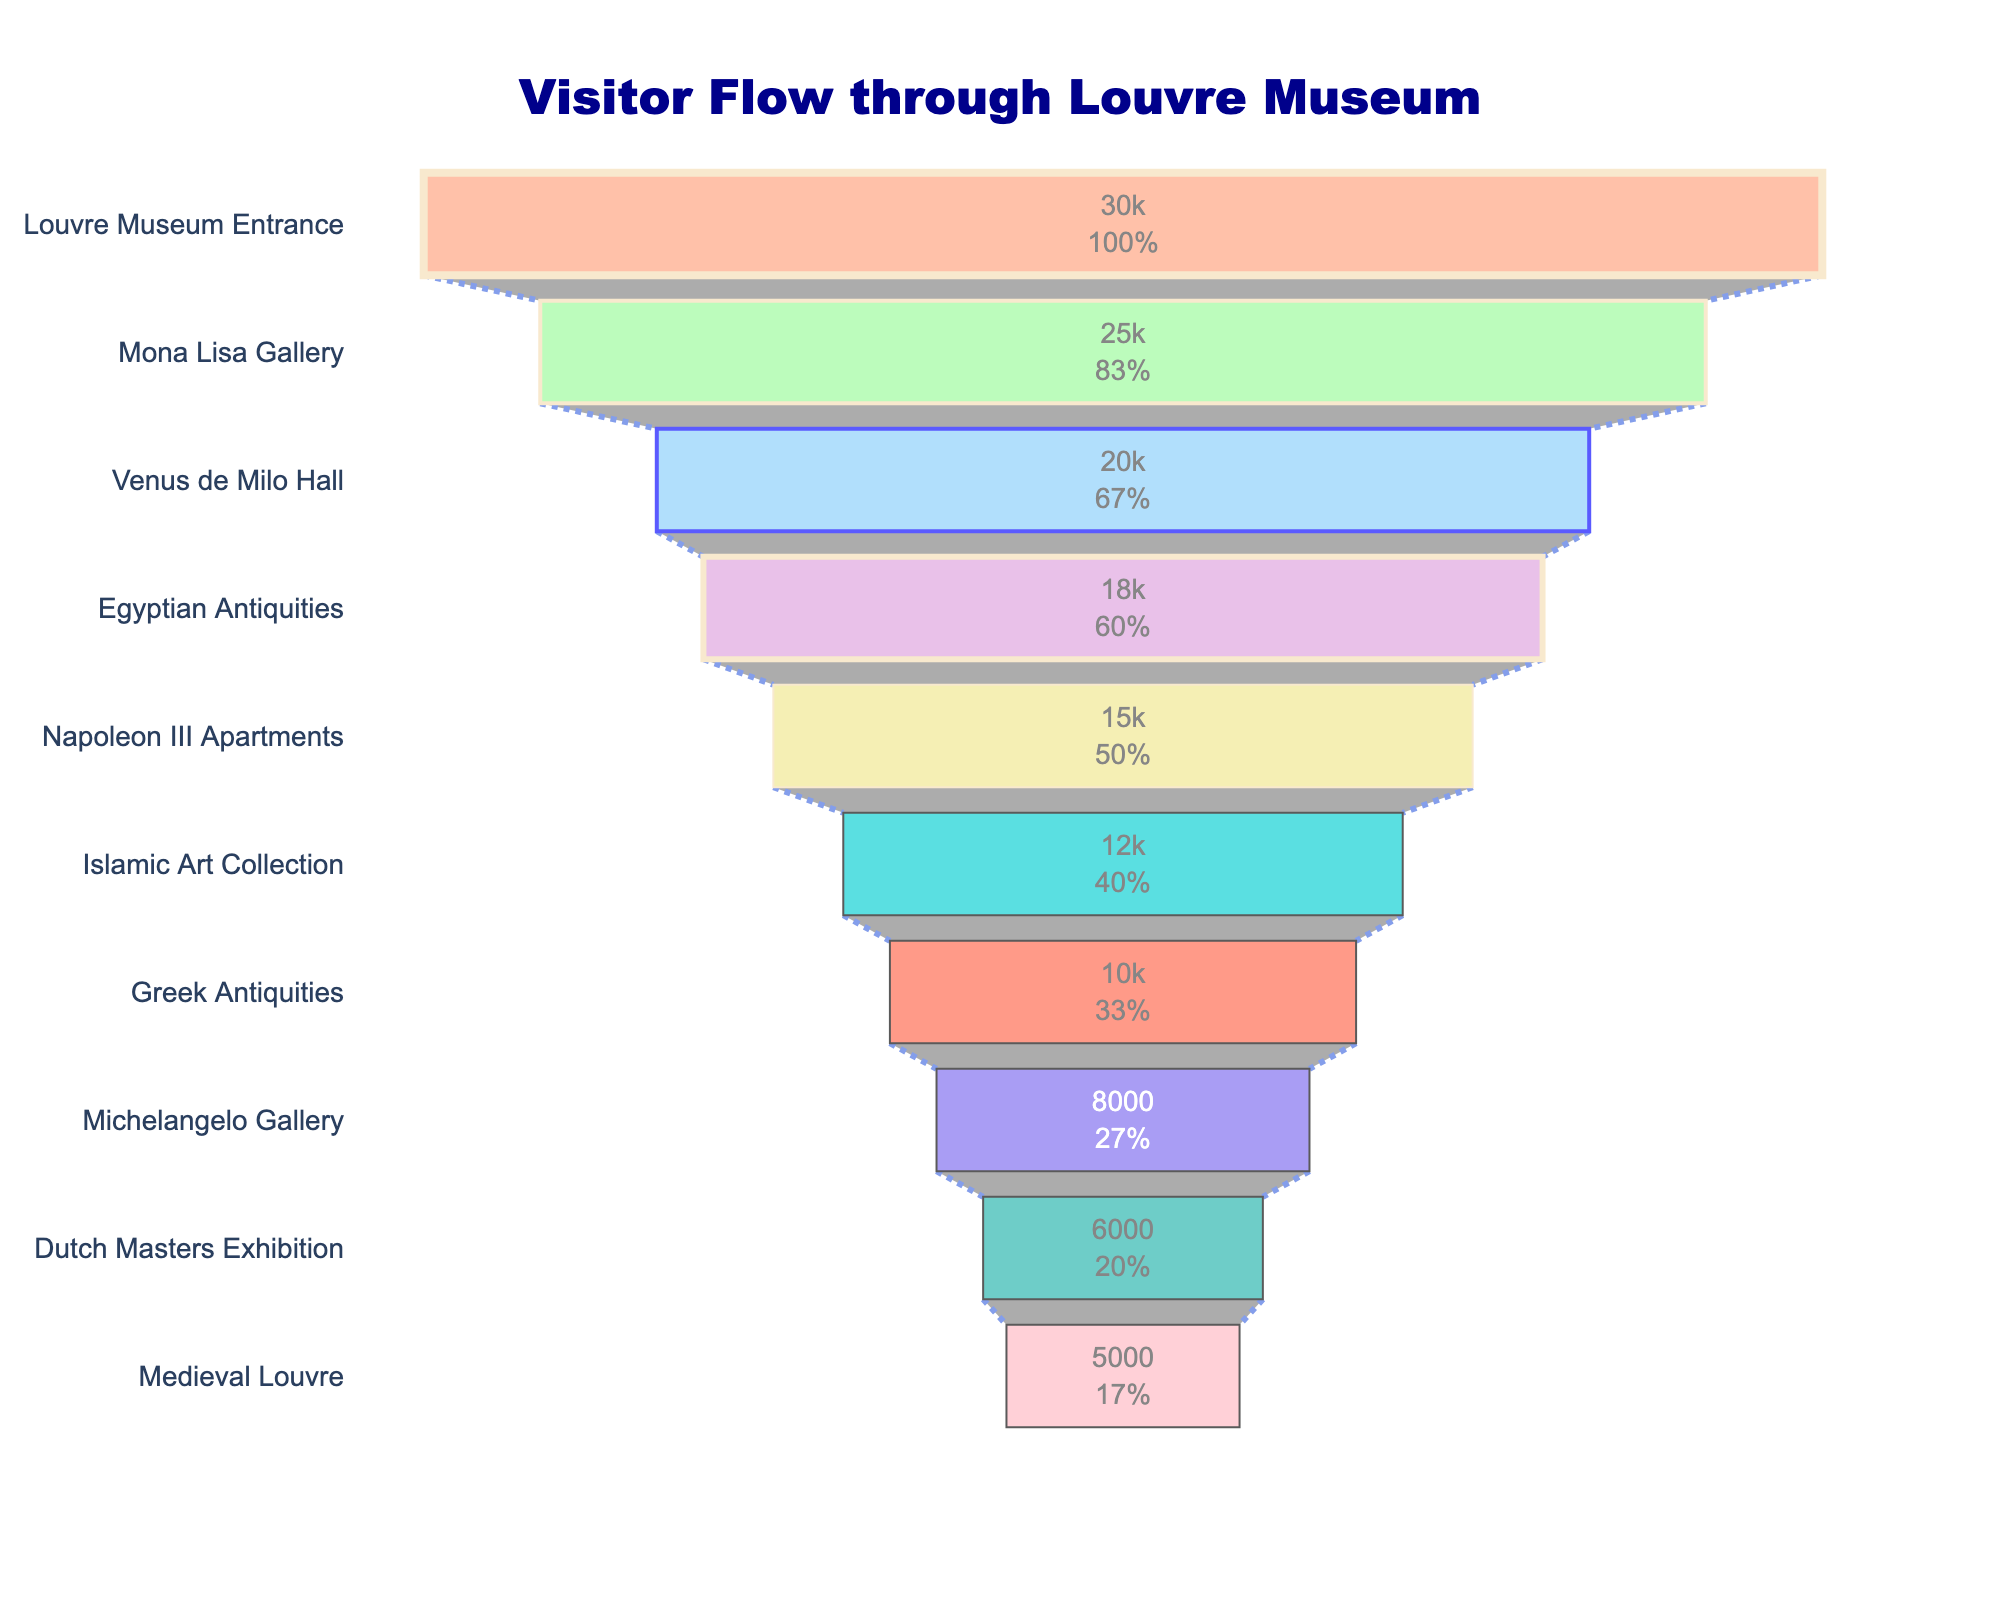What is the title of the funnel chart? The title of the funnel chart is at the top of the chart. It reads "Visitor Flow through Louvre Museum".
Answer: Visitor Flow through Louvre Museum Which exhibit has the highest number of visitors? The highest number of visitors is represented at the top of the funnel. The exhibit at the top is the "Louvre Museum Entrance" with 30,000 visitors.
Answer: Louvre Museum Entrance How many visitors enter the Mona Lisa Gallery? The funnel section for the Mona Lisa Gallery shows the number of visitors inside the shape. It shows 25,000 visitors.
Answer: 25,000 What is the total number of visitors that did not reach the Dutch Masters Exhibition after entering the Louvre Museum? Starting with the Louvre Museum Entrance with 30,000 visitors, subtract the 6,000 visitors that reach the Dutch Masters Exhibition: 30,000 - 6,000 = 24,000.
Answer: 24,000 Which exhibit has the largest drop in visitor numbers compared to the previous exhibit? By comparing the numbers, the exhibit with the largest decrease is from "Mona Lisa Gallery" (25,000) to "Venus de Milo Hall" (20,000), a difference of 5,000 visitors.
Answer: Venus de Milo Hall How many fewer visitors are there at the Michelangelo Gallery compared to the Greek Antiquities? The difference in visitor numbers between Greek Antiquities (10,000) and Michelangelo Gallery (8,000) is calculated: 10,000 - 8,000 = 2,000.
Answer: 2,000 What percentage of visitors reach the Napoleon III Apartments relative to the initial number of visitors at the Louvre Museum Entrance? The number of visitors at Napoleon III Apartments is 15,000. To find the percentage relative to 30,000 visitors at the entrance: (15,000 / 30,000) * 100 = 50%.
Answer: 50% By how much does the visitor count decrease from the Islamic Art Collection to Medieval Louvre? The visitor count at Islamic Art Collection is 12,000, and at Medieval Louvre is 5,000. The difference: 12,000 - 5,000 = 7,000.
Answer: 7,000 What is the proportion of visitors that remain at the Greek Antiquities out of those who started at Louvre Museum Entrance? The number reaching Greek Antiquities is 10,000. The initial number of visitors is 30,000: (10,000 / 30,000) = 1/3 or approximately 33.3%.
Answer: 33.3% If the number of visitors from the Mona Lisa Gallery to the Dutch Masters Exhibition drops by the same percentage at each level, what is the average drop in visitor numbers between each exhibit? The overall drop from Mona Lisa Gallery (25,000) to Dutch Masters Exhibition (6,000) is 25,000 - 6,000 = 19,000. There are 8 levels between them (Mona Lisa, Venus de Milo, Egyptian Antiquities, Napoleon III, Islamic Art, Greek Antiquities, Michelangelo, Dutch Masters). The average drop per level is 19,000 / 8 = 2,375.
Answer: 2,375 